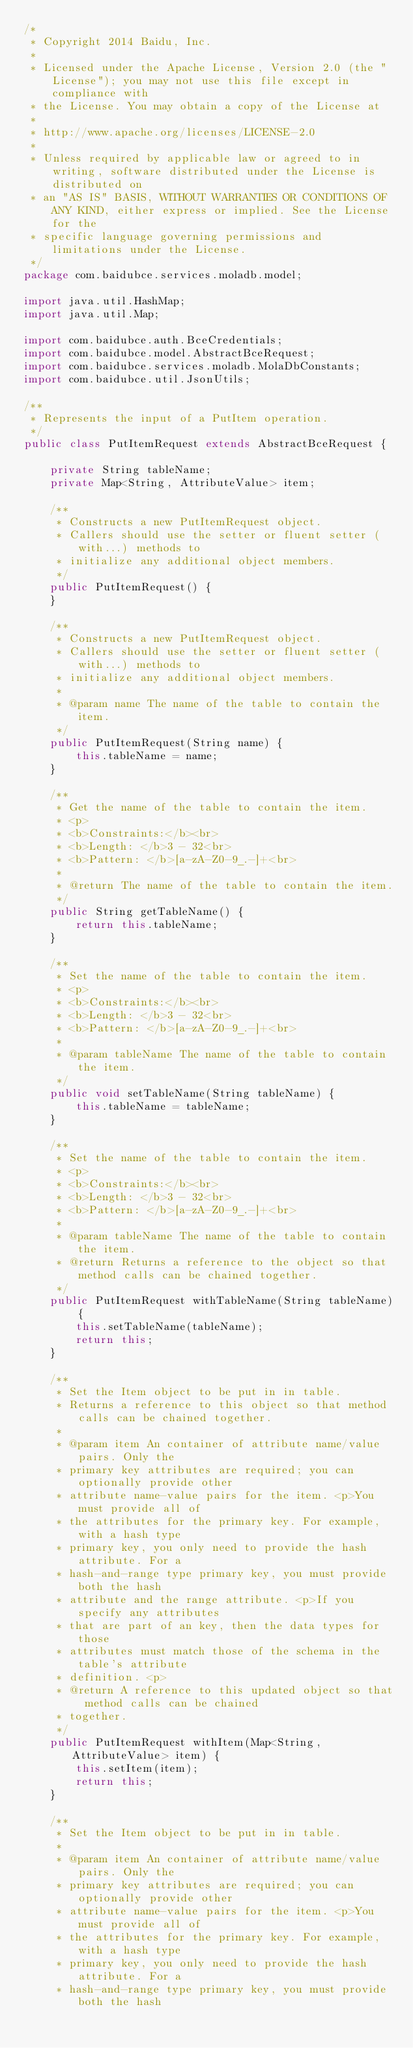Convert code to text. <code><loc_0><loc_0><loc_500><loc_500><_Java_>/*
 * Copyright 2014 Baidu, Inc.
 *
 * Licensed under the Apache License, Version 2.0 (the "License"); you may not use this file except in compliance with
 * the License. You may obtain a copy of the License at
 *
 * http://www.apache.org/licenses/LICENSE-2.0
 *
 * Unless required by applicable law or agreed to in writing, software distributed under the License is distributed on
 * an "AS IS" BASIS, WITHOUT WARRANTIES OR CONDITIONS OF ANY KIND, either express or implied. See the License for the
 * specific language governing permissions and limitations under the License.
 */
package com.baidubce.services.moladb.model;

import java.util.HashMap;
import java.util.Map;

import com.baidubce.auth.BceCredentials;
import com.baidubce.model.AbstractBceRequest;
import com.baidubce.services.moladb.MolaDbConstants;
import com.baidubce.util.JsonUtils;

/**
 * Represents the input of a PutItem operation.
 */
public class PutItemRequest extends AbstractBceRequest {

    private String tableName;
    private Map<String, AttributeValue> item;

    /**
     * Constructs a new PutItemRequest object.
     * Callers should use the setter or fluent setter (with...) methods to
     * initialize any additional object members.
     */
    public PutItemRequest() {
    }

    /**
     * Constructs a new PutItemRequest object.
     * Callers should use the setter or fluent setter (with...) methods to
     * initialize any additional object members.
     *
     * @param name The name of the table to contain the item.
     */
    public PutItemRequest(String name) {
        this.tableName = name;
    }

    /**
     * Get the name of the table to contain the item.
     * <p>
     * <b>Constraints:</b><br>
     * <b>Length: </b>3 - 32<br>
     * <b>Pattern: </b>[a-zA-Z0-9_.-]+<br>
     *
     * @return The name of the table to contain the item.
     */
    public String getTableName() {
        return this.tableName;
    }

    /**
     * Set the name of the table to contain the item.
     * <p>
     * <b>Constraints:</b><br>
     * <b>Length: </b>3 - 32<br>
     * <b>Pattern: </b>[a-zA-Z0-9_.-]+<br>
     *
     * @param tableName The name of the table to contain the item.
     */
    public void setTableName(String tableName) {
        this.tableName = tableName;
    }

    /**
     * Set the name of the table to contain the item.
     * <p>
     * <b>Constraints:</b><br>
     * <b>Length: </b>3 - 32<br>
     * <b>Pattern: </b>[a-zA-Z0-9_.-]+<br>
     *
     * @param tableName The name of the table to contain the item.
     * @return Returns a reference to the object so that method calls can be chained together.
     */
    public PutItemRequest withTableName(String tableName) {
        this.setTableName(tableName);
        return this;
    }

    /**
     * Set the Item object to be put in in table.
     * Returns a reference to this object so that method calls can be chained together.
     *
     * @param item An container of attribute name/value pairs. Only the
     * primary key attributes are required; you can optionally provide other
     * attribute name-value pairs for the item. <p>You must provide all of
     * the attributes for the primary key. For example, with a hash type
     * primary key, you only need to provide the hash attribute. For a
     * hash-and-range type primary key, you must provide both the hash
     * attribute and the range attribute. <p>If you specify any attributes
     * that are part of an key, then the data types for those
     * attributes must match those of the schema in the table's attribute
     * definition. <p>
     * @return A reference to this updated object so that method calls can be chained
     * together.
     */
    public PutItemRequest withItem(Map<String, AttributeValue> item) {
        this.setItem(item);
        return this;
    }

    /**
     * Set the Item object to be put in in table.
     *
     * @param item An container of attribute name/value pairs. Only the
     * primary key attributes are required; you can optionally provide other
     * attribute name-value pairs for the item. <p>You must provide all of
     * the attributes for the primary key. For example, with a hash type
     * primary key, you only need to provide the hash attribute. For a
     * hash-and-range type primary key, you must provide both the hash</code> 